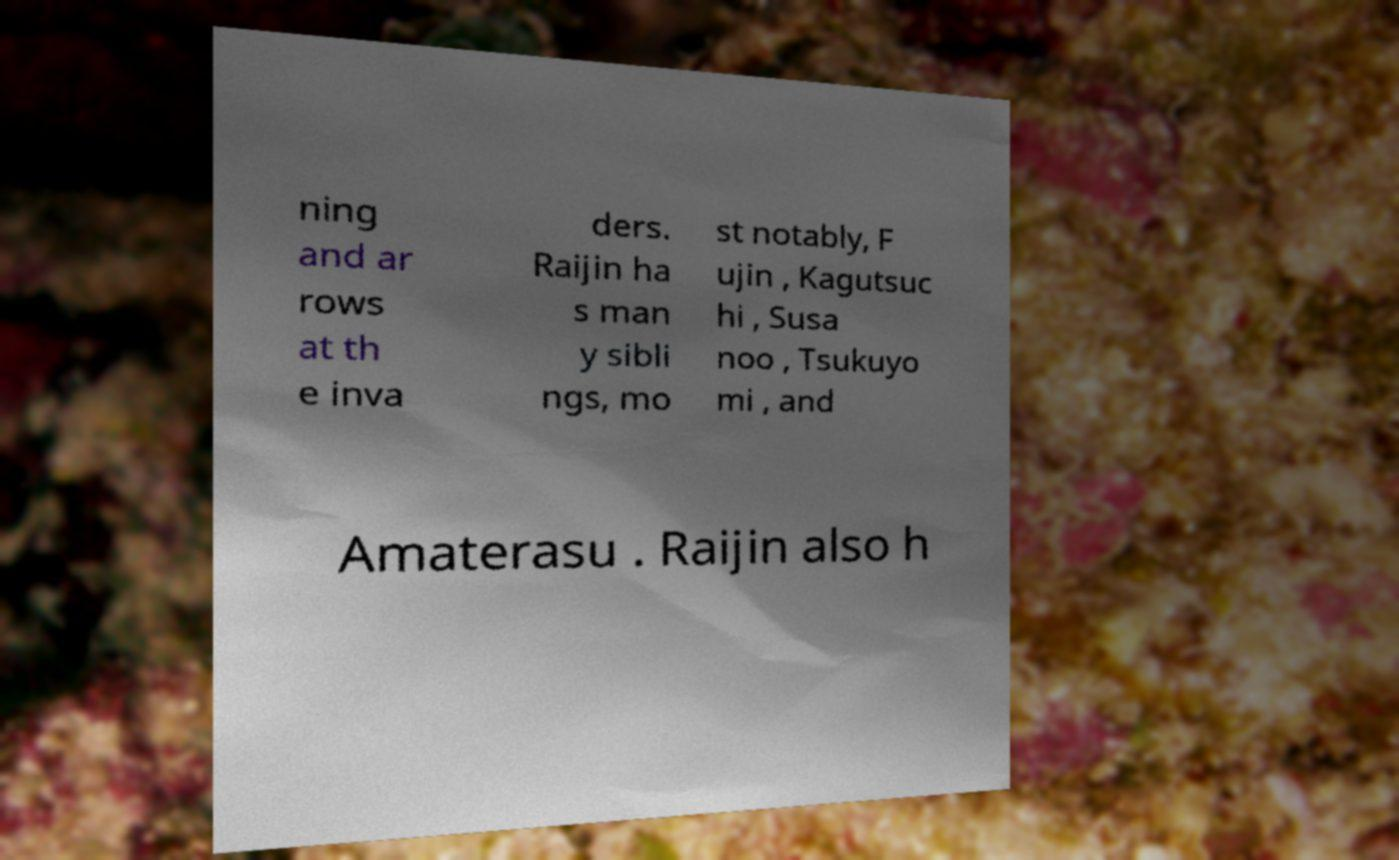Please read and relay the text visible in this image. What does it say? ning and ar rows at th e inva ders. Raijin ha s man y sibli ngs, mo st notably, F ujin , Kagutsuc hi , Susa noo , Tsukuyo mi , and Amaterasu . Raijin also h 